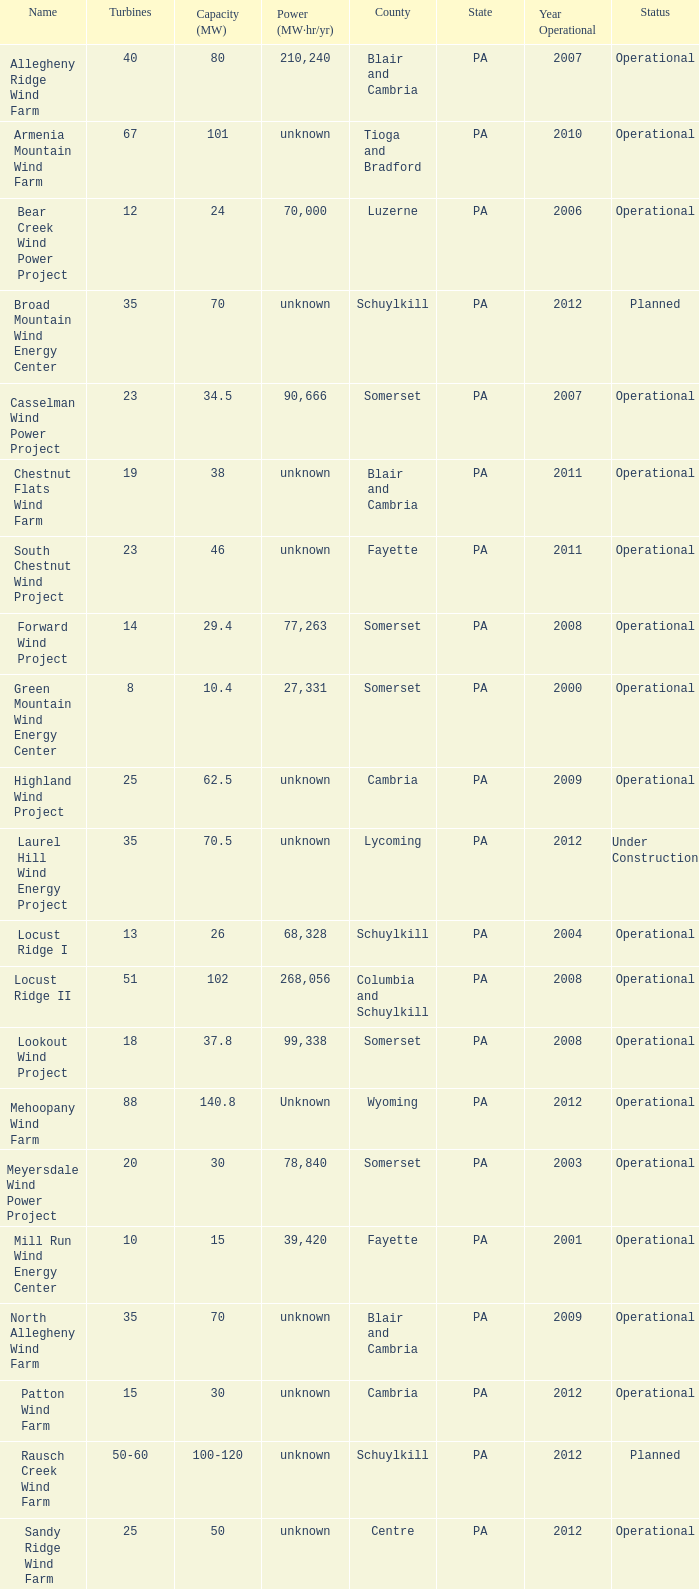What year was Fayette operational at 46? 2011.0. 